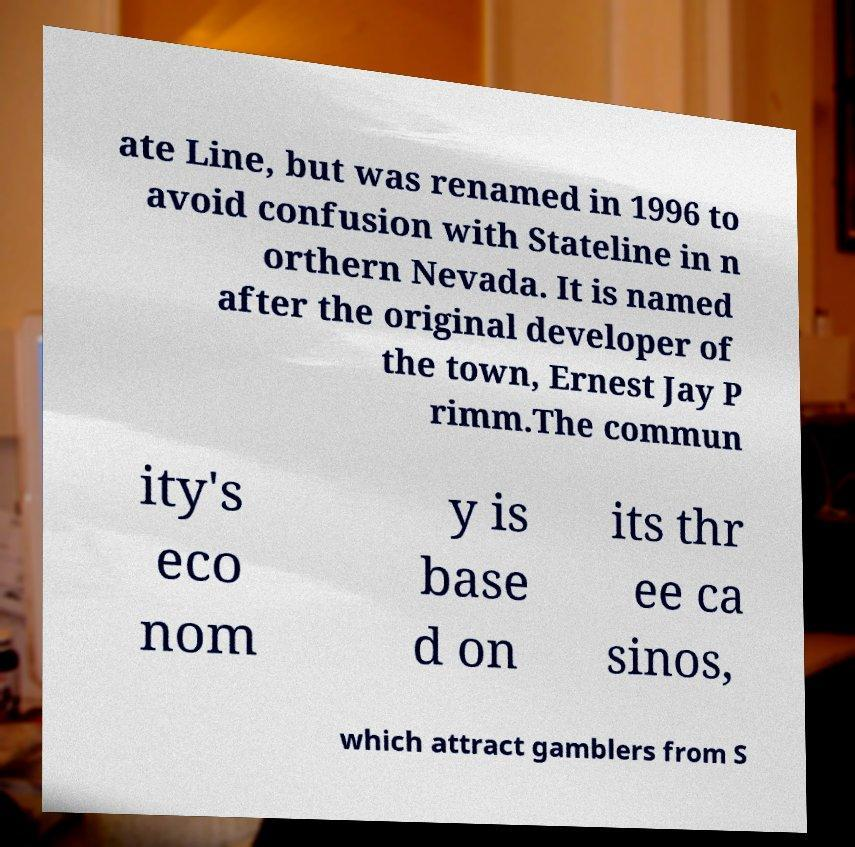Could you assist in decoding the text presented in this image and type it out clearly? ate Line, but was renamed in 1996 to avoid confusion with Stateline in n orthern Nevada. It is named after the original developer of the town, Ernest Jay P rimm.The commun ity's eco nom y is base d on its thr ee ca sinos, which attract gamblers from S 